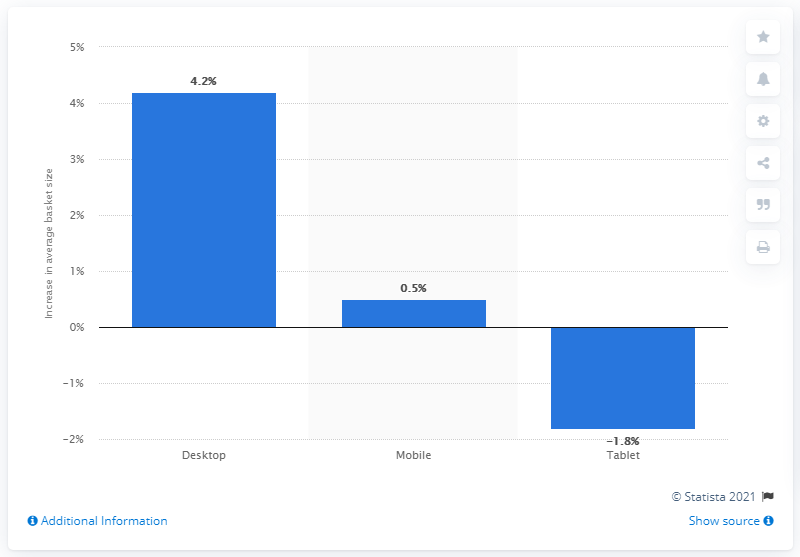Identify some key points in this picture. In 2015, there were 22,500 desktop computers in use, and in 2016, that number had increased by 4.2% to reach 23,500 desktop computers. 